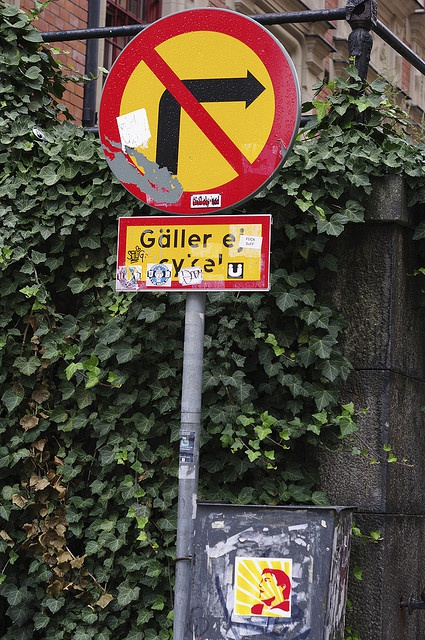Describe the objects in this image and their specific colors. I can see various objects in this image with different colors. 